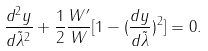Convert formula to latex. <formula><loc_0><loc_0><loc_500><loc_500>\frac { d ^ { 2 } y } { d \tilde { \lambda } ^ { 2 } } + \frac { 1 } { 2 } \frac { W ^ { \prime } } { W } [ 1 - ( \frac { d y } { d \tilde { \lambda } } ) ^ { 2 } ] = 0 .</formula> 